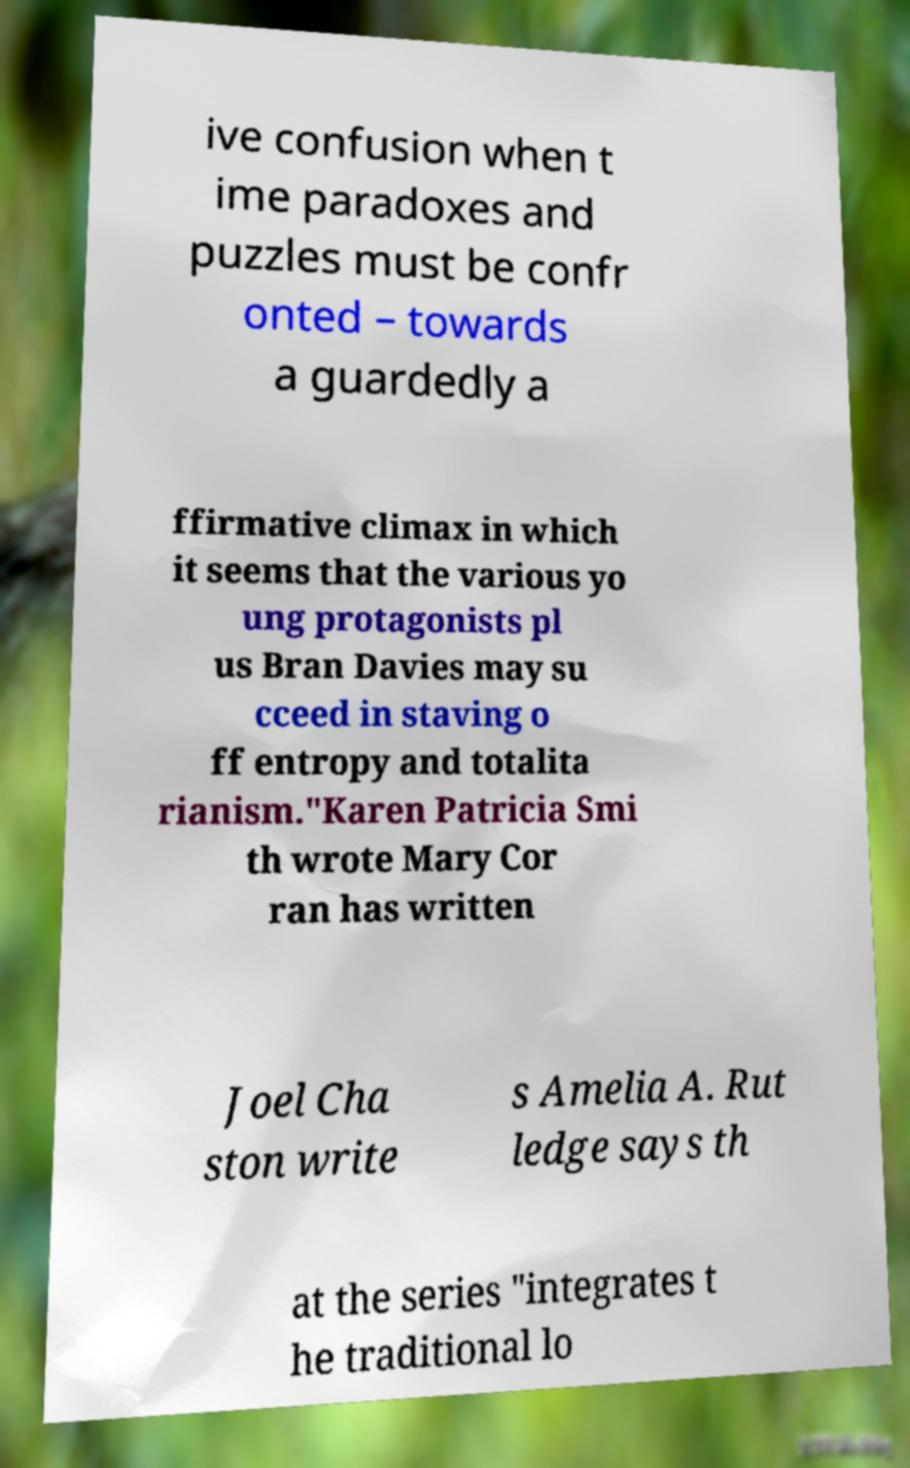For documentation purposes, I need the text within this image transcribed. Could you provide that? ive confusion when t ime paradoxes and puzzles must be confr onted – towards a guardedly a ffirmative climax in which it seems that the various yo ung protagonists pl us Bran Davies may su cceed in staving o ff entropy and totalita rianism."Karen Patricia Smi th wrote Mary Cor ran has written Joel Cha ston write s Amelia A. Rut ledge says th at the series "integrates t he traditional lo 